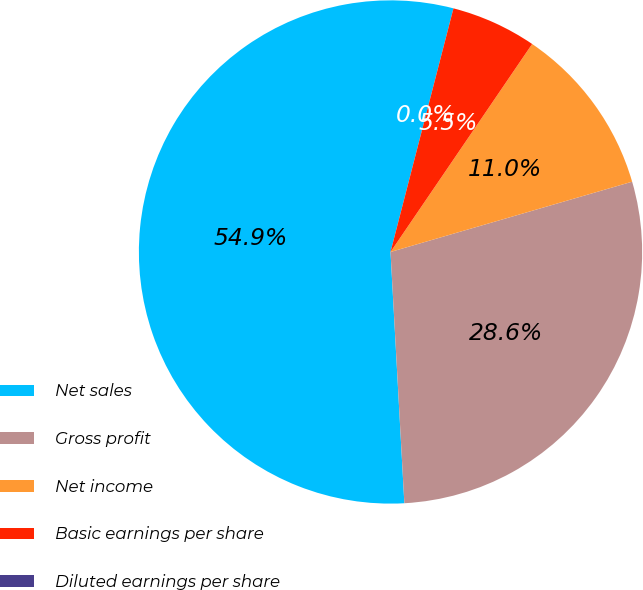Convert chart to OTSL. <chart><loc_0><loc_0><loc_500><loc_500><pie_chart><fcel>Net sales<fcel>Gross profit<fcel>Net income<fcel>Basic earnings per share<fcel>Diluted earnings per share<nl><fcel>54.9%<fcel>28.63%<fcel>10.98%<fcel>5.49%<fcel>0.0%<nl></chart> 